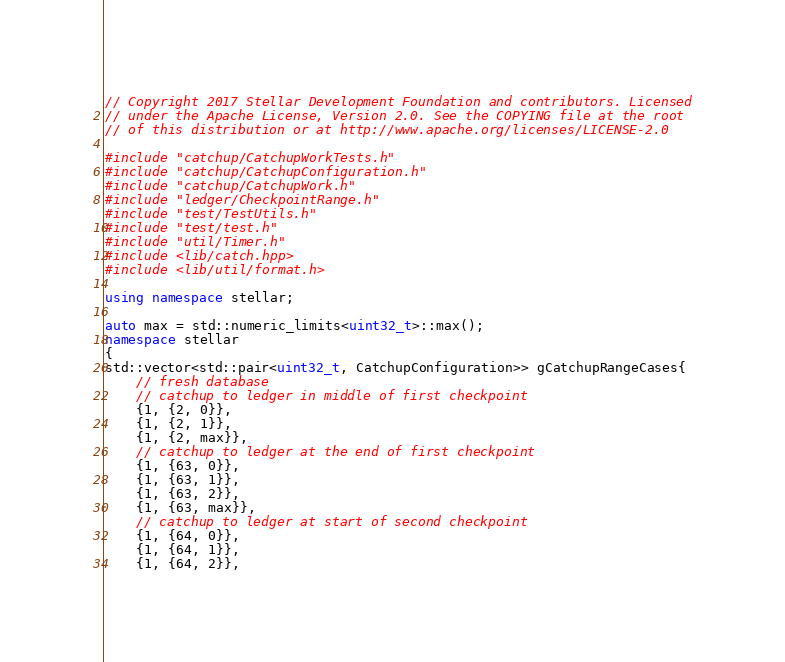<code> <loc_0><loc_0><loc_500><loc_500><_C++_>// Copyright 2017 Stellar Development Foundation and contributors. Licensed
// under the Apache License, Version 2.0. See the COPYING file at the root
// of this distribution or at http://www.apache.org/licenses/LICENSE-2.0

#include "catchup/CatchupWorkTests.h"
#include "catchup/CatchupConfiguration.h"
#include "catchup/CatchupWork.h"
#include "ledger/CheckpointRange.h"
#include "test/TestUtils.h"
#include "test/test.h"
#include "util/Timer.h"
#include <lib/catch.hpp>
#include <lib/util/format.h>

using namespace stellar;

auto max = std::numeric_limits<uint32_t>::max();
namespace stellar
{
std::vector<std::pair<uint32_t, CatchupConfiguration>> gCatchupRangeCases{
    // fresh database
    // catchup to ledger in middle of first checkpoint
    {1, {2, 0}},
    {1, {2, 1}},
    {1, {2, max}},
    // catchup to ledger at the end of first checkpoint
    {1, {63, 0}},
    {1, {63, 1}},
    {1, {63, 2}},
    {1, {63, max}},
    // catchup to ledger at start of second checkpoint
    {1, {64, 0}},
    {1, {64, 1}},
    {1, {64, 2}},</code> 